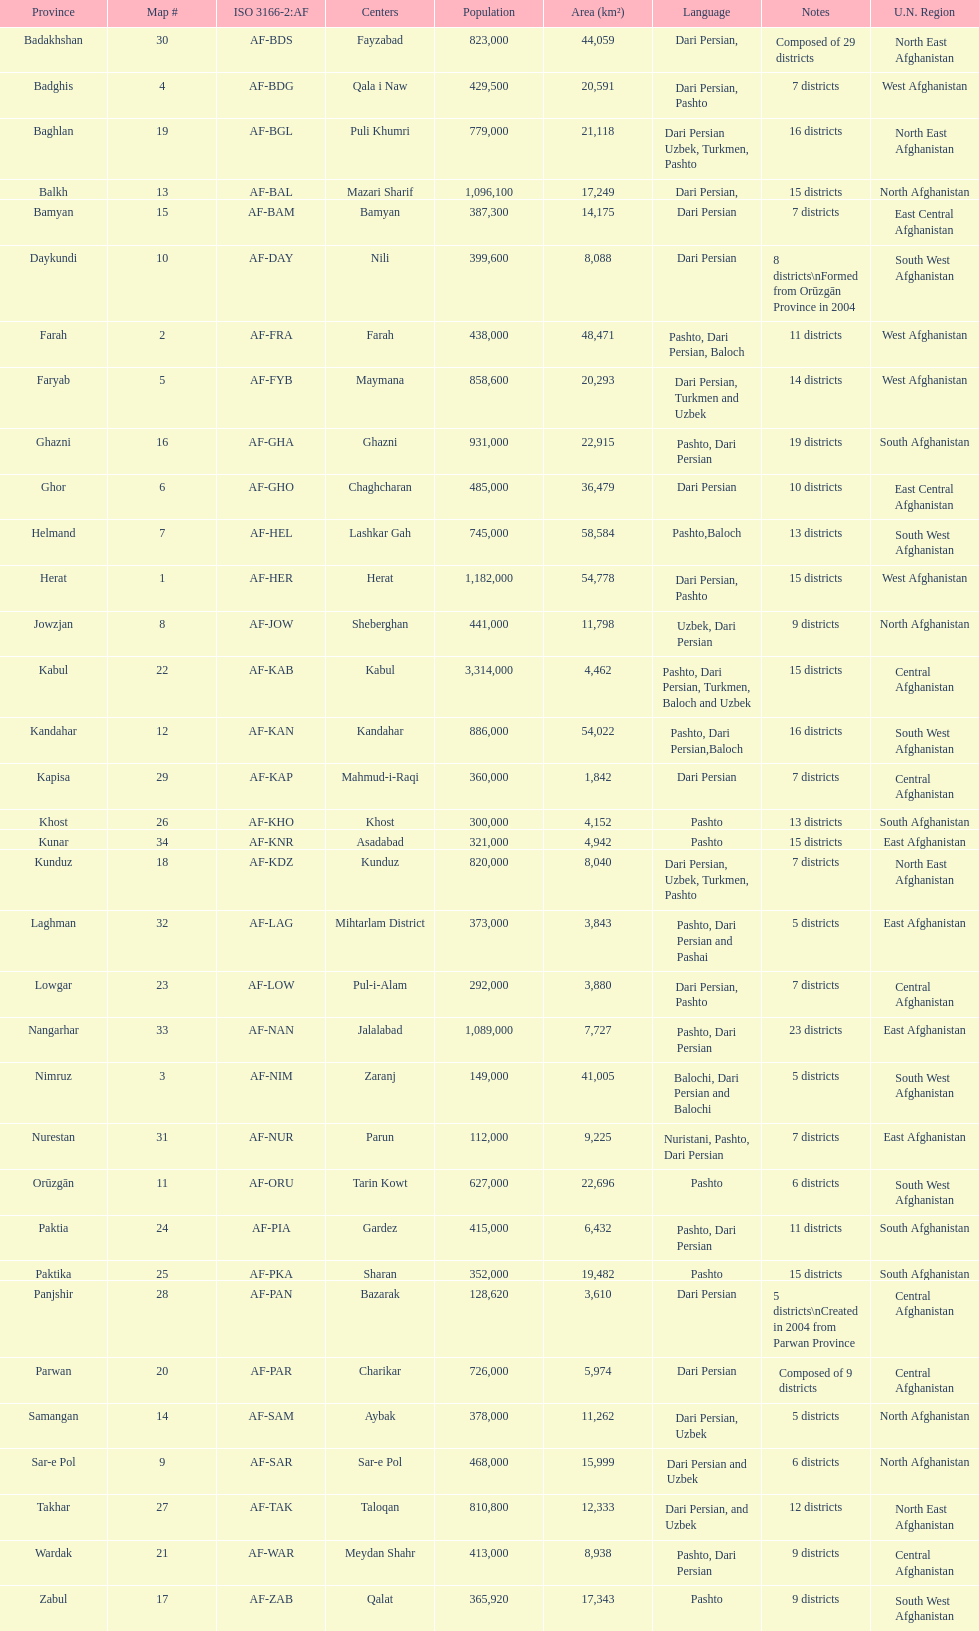How many provinces in afghanistan speak dari persian? 28. 